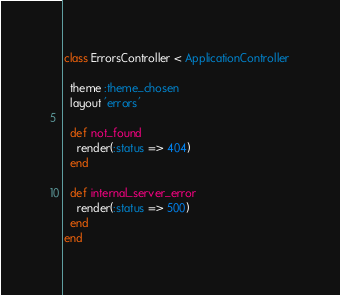Convert code to text. <code><loc_0><loc_0><loc_500><loc_500><_Ruby_>class ErrorsController < ApplicationController

  theme :theme_chosen
  layout 'errors'

  def not_found
    render(:status => 404)
  end

  def internal_server_error
    render(:status => 500)
  end
end
</code> 